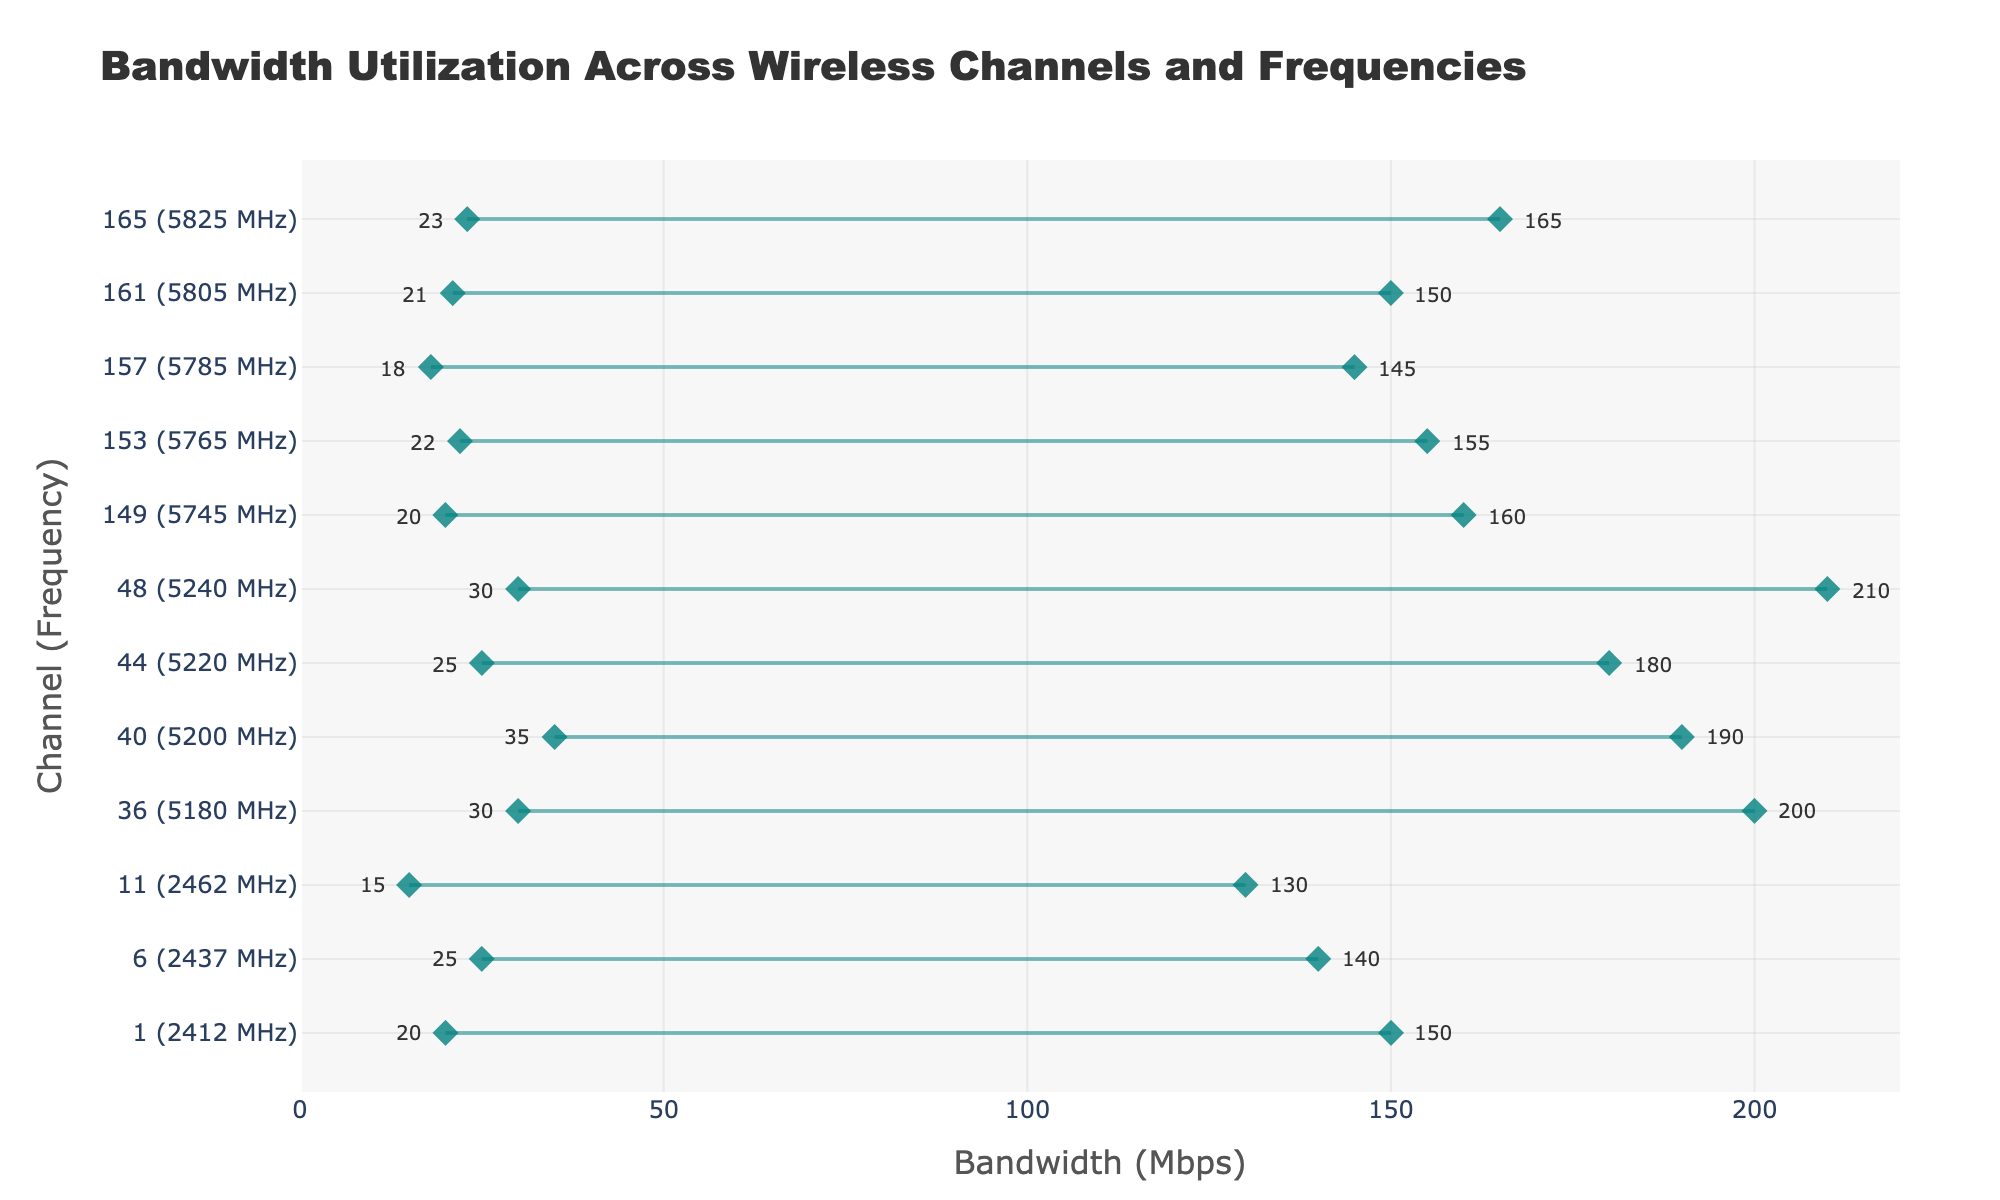What's the title of the plot? The title is usually found at the top of the plot to describe its purpose. Here, the title reads "Bandwidth Utilization Across Wireless Channels and Frequencies".
Answer: Bandwidth Utilization Across Wireless Channels and Frequencies What is the range of bandwidth for Channel 36 (5180 MHz)? Locate Channel 36 on the vertical axis, which corresponds to 5180 MHz. The plot shows the minimum and maximum bandwidth values for this channel as endpoints of the horizontal line.
Answer: 30 - 200 Mbps Which channel has the highest maximum bandwidth? Look for the highest endpoint on the 'Bandwidth (Mbps)' axis. The annotated values next to the markers make it easy to see that Channel 48 (5240 MHz) reaches a maximum of 210 Mbps, the highest in the plot.
Answer: Channel 48 (5240 MHz) How does the minimum bandwidth of Channel 1 (2412 MHz) compare to Channel 40 (5200 MHz)? Find the markers for Channels 1 and 40. Channel 1 has a minimum bandwidth of 20 Mbps, whereas Channel 40 has a minimum of 35 Mbps. Channel 40's minimum is higher.
Answer: Channel 40's minimum is higher by 15 Mbps What is the average of the maximum bandwidth values for Channels 36, 40, and 48 in the 5 GHz band? Channel 36 (200 Mbps), Channel 40 (190 Mbps), and Channel 48 (210 Mbps). Sum these values (200 + 190 + 210) and divide by the number of channels, which is 3.
Answer: 200 Mbps Which channel has the narrowest bandwidth range, and what is this range? The narrowest range will be the smallest difference between the minimum and maximum bandwidth values. Channel 11 has a bandwidth range of 115 Mbps (130 - 15). Check the plot to verify.
Answer: Channel 11, 115 Mbps What is the frequency of the channel with the lowest minimum bandwidth? Look at the bottom endpoints of the lines to find the smallest bandwidth. Channel 11 has the lowest minimum bandwidth at 15 Mbps.
Answer: 2462 MHz (Channel 11) How many channels have both their minimum and maximum bandwidth values above 20 Mbps? Count the lines where the lower endpoint (minimum) and upper endpoint (maximum) are both above 20 Mbps. Channels 6, 36, 40, 44, 48, 153, 157, 161, and 165 meet this criterion.
Answer: 9 channels Among channels operating at frequencies above 5700 MHz, which one has the highest minimum bandwidth? Look at channels with frequencies above 5700 MHz and compare their minimum bandwidth values. Channel 165 has the highest minimum bandwidth of 23 Mbps.
Answer: Channel 165 (5825 MHz) Is there a relationship between the frequency of the channel and the bandwidth range? Observe the plot to identify trends. Channels in the 2.4 GHz band (low frequencies) tend to have lower maximum bandwidths compared to those in the 5 GHz band (high frequencies). Generally, higher frequencies have larger bandwidth ranges.
Answer: Higher frequencies generally have larger bandwidth ranges 